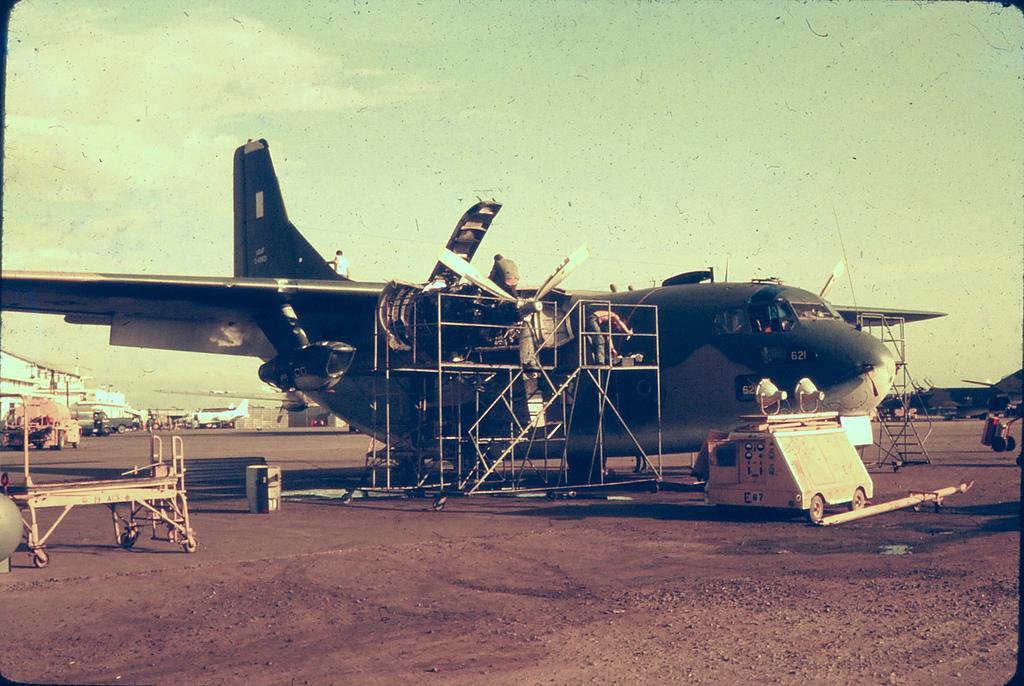Could you give a brief overview of what you see in this image? In this image we can see many aircrafts. We can see the sky in the image. There are few people in the image. There are few objects in the image. 